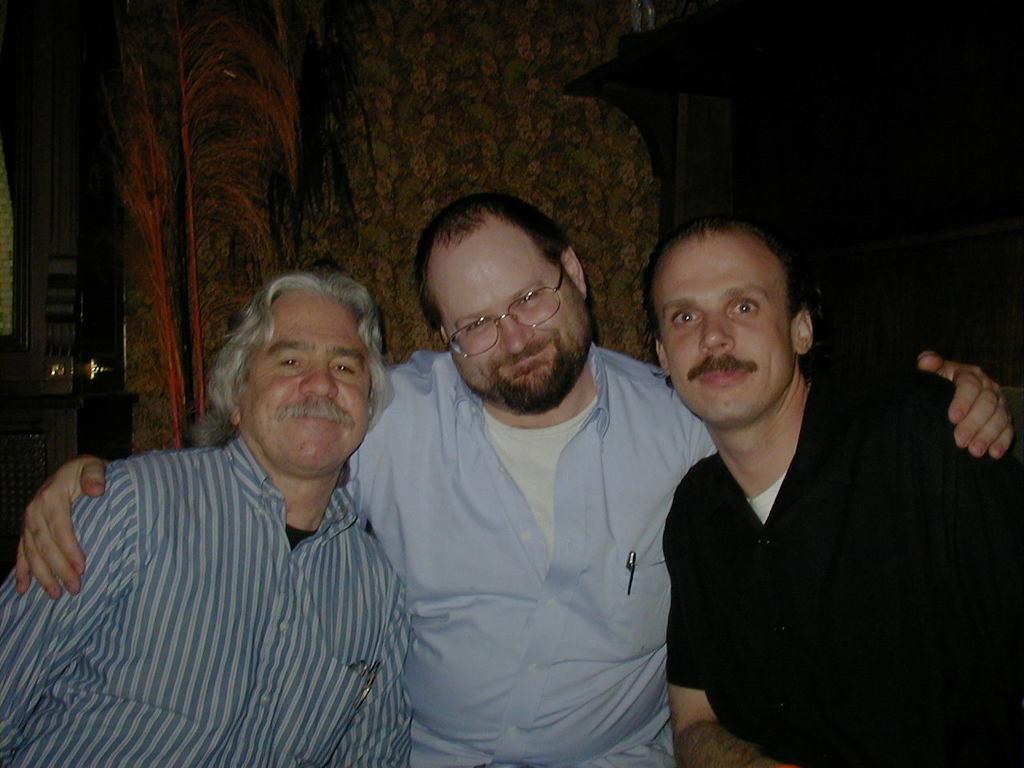Please provide a concise description of this image. In the image we can see three men wearing clothes. This is a pen, spectacles and wall. And half the background is blurred. 